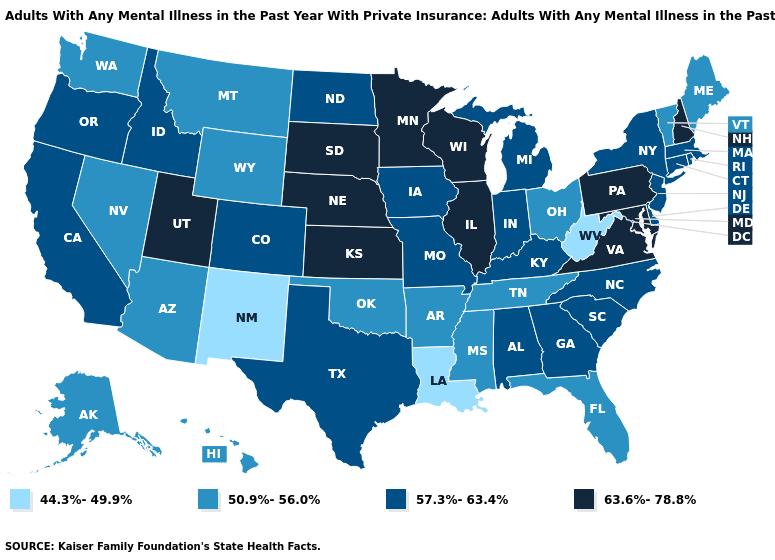Name the states that have a value in the range 57.3%-63.4%?
Answer briefly. Alabama, California, Colorado, Connecticut, Delaware, Georgia, Idaho, Indiana, Iowa, Kentucky, Massachusetts, Michigan, Missouri, New Jersey, New York, North Carolina, North Dakota, Oregon, Rhode Island, South Carolina, Texas. Does the map have missing data?
Quick response, please. No. What is the value of Montana?
Keep it brief. 50.9%-56.0%. Name the states that have a value in the range 63.6%-78.8%?
Concise answer only. Illinois, Kansas, Maryland, Minnesota, Nebraska, New Hampshire, Pennsylvania, South Dakota, Utah, Virginia, Wisconsin. What is the value of Oklahoma?
Write a very short answer. 50.9%-56.0%. What is the value of California?
Answer briefly. 57.3%-63.4%. What is the value of Connecticut?
Keep it brief. 57.3%-63.4%. What is the value of Rhode Island?
Be succinct. 57.3%-63.4%. Does Rhode Island have a lower value than Pennsylvania?
Quick response, please. Yes. Name the states that have a value in the range 57.3%-63.4%?
Short answer required. Alabama, California, Colorado, Connecticut, Delaware, Georgia, Idaho, Indiana, Iowa, Kentucky, Massachusetts, Michigan, Missouri, New Jersey, New York, North Carolina, North Dakota, Oregon, Rhode Island, South Carolina, Texas. Name the states that have a value in the range 63.6%-78.8%?
Give a very brief answer. Illinois, Kansas, Maryland, Minnesota, Nebraska, New Hampshire, Pennsylvania, South Dakota, Utah, Virginia, Wisconsin. Name the states that have a value in the range 50.9%-56.0%?
Keep it brief. Alaska, Arizona, Arkansas, Florida, Hawaii, Maine, Mississippi, Montana, Nevada, Ohio, Oklahoma, Tennessee, Vermont, Washington, Wyoming. Does Kentucky have the same value as Massachusetts?
Answer briefly. Yes. Does the first symbol in the legend represent the smallest category?
Short answer required. Yes. Does the map have missing data?
Keep it brief. No. 